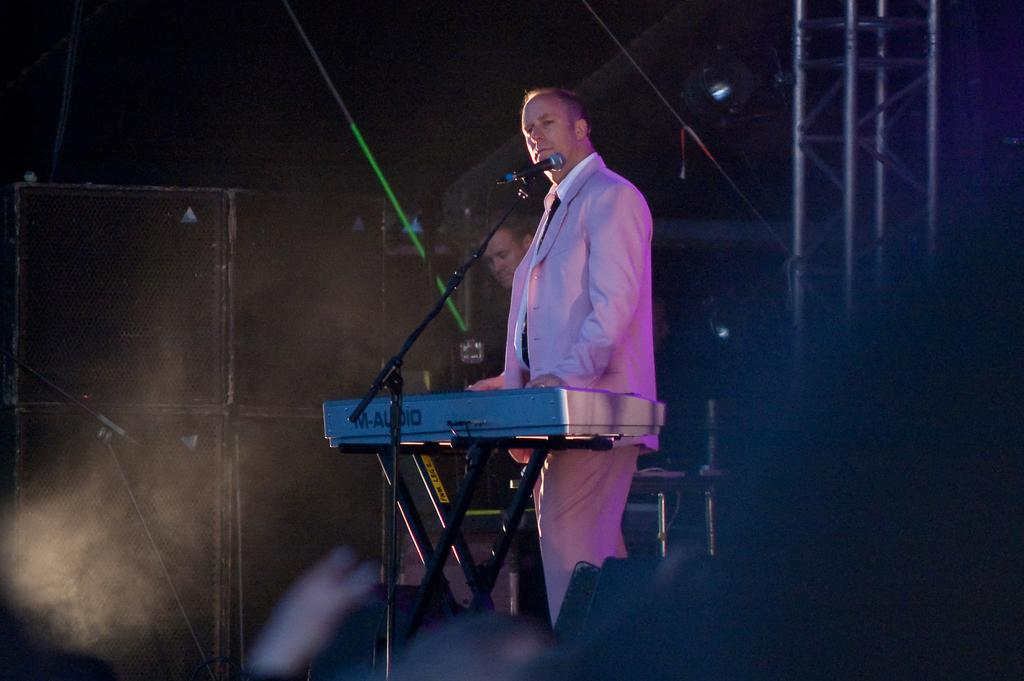What is the main object in the middle of the image? There is a microphone and a piano in the middle of the image. What are the two persons doing in the image? The two persons are standing behind the piano. What can be seen in the background of the image? There are poles visible in the background of the image. What type of soup is being served in the image? There is no soup present in the image. What color is the crayon used by the person in the image? There is no person using a crayon in the image. 